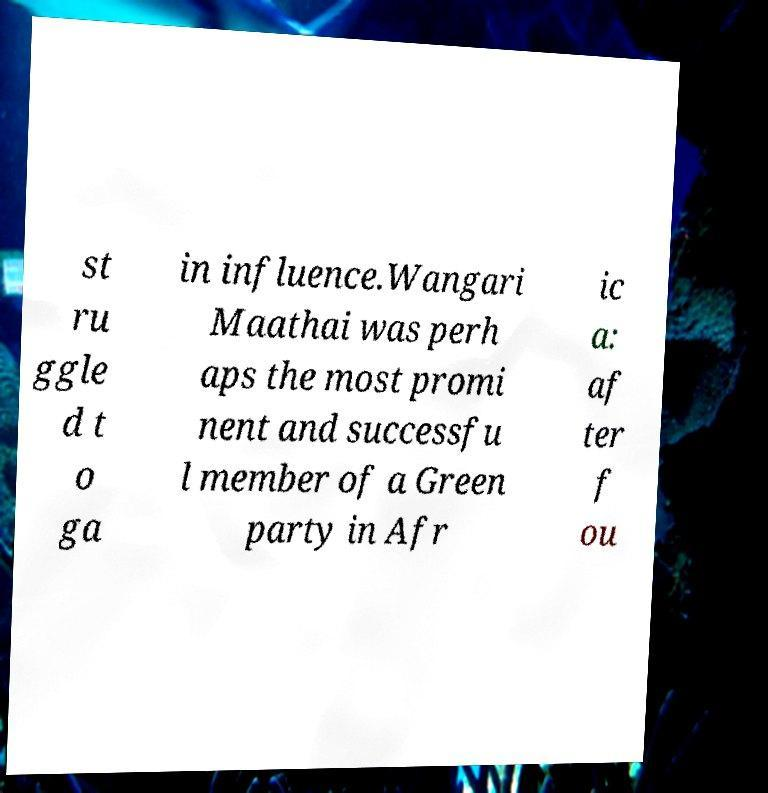What messages or text are displayed in this image? I need them in a readable, typed format. st ru ggle d t o ga in influence.Wangari Maathai was perh aps the most promi nent and successfu l member of a Green party in Afr ic a: af ter f ou 